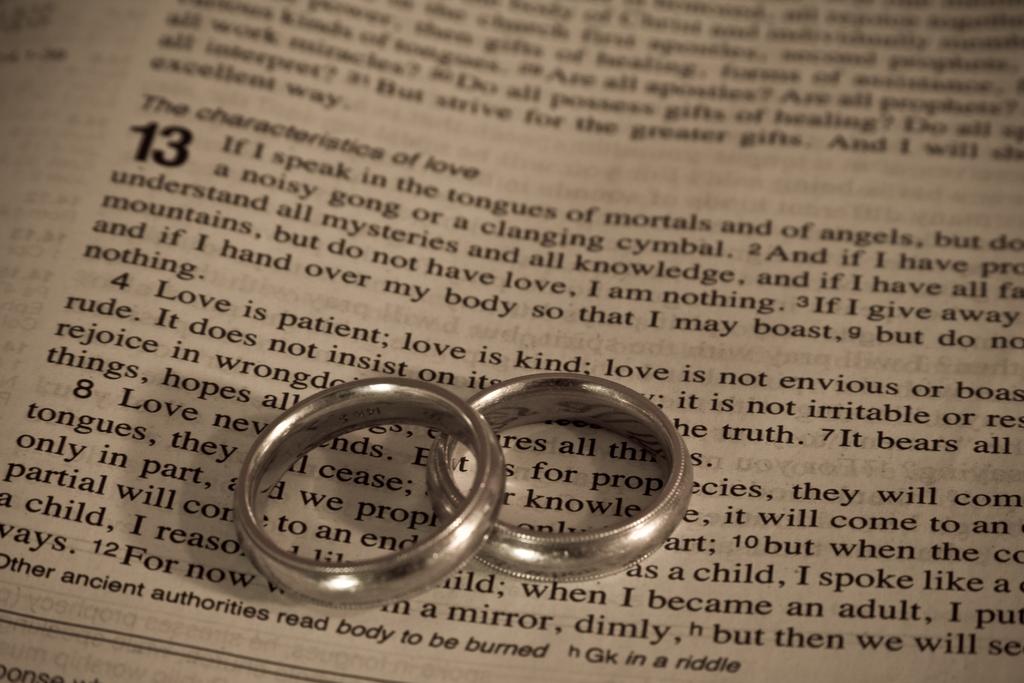What is the topic that the characteristic describe?
Your response must be concise. Love. What is the boldest number?
Give a very brief answer. 13. 